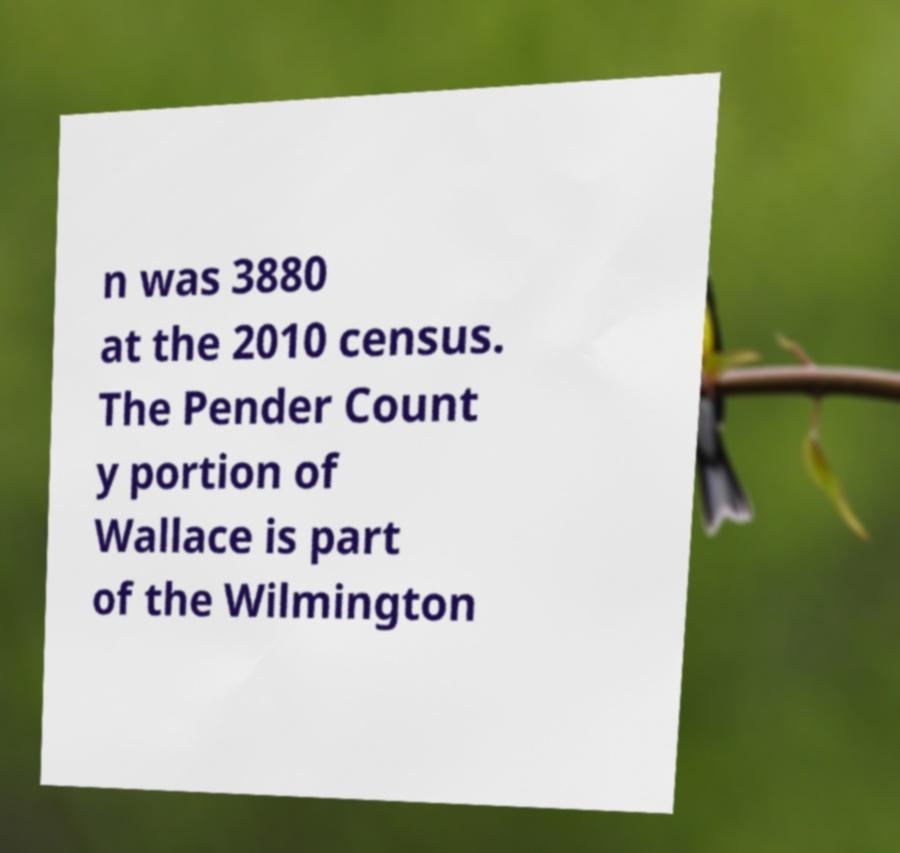What messages or text are displayed in this image? I need them in a readable, typed format. n was 3880 at the 2010 census. The Pender Count y portion of Wallace is part of the Wilmington 